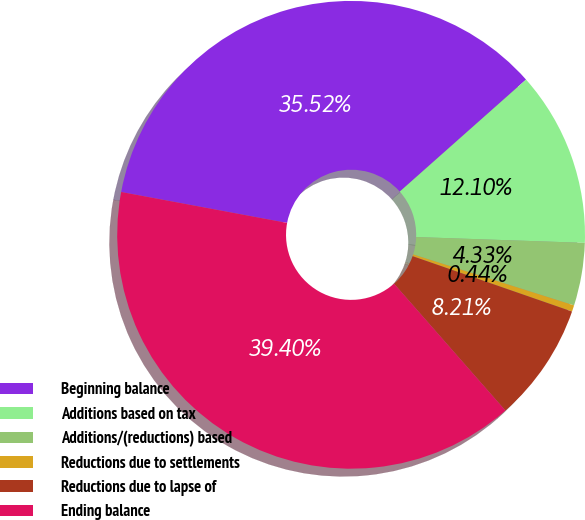<chart> <loc_0><loc_0><loc_500><loc_500><pie_chart><fcel>Beginning balance<fcel>Additions based on tax<fcel>Additions/(reductions) based<fcel>Reductions due to settlements<fcel>Reductions due to lapse of<fcel>Ending balance<nl><fcel>35.52%<fcel>12.1%<fcel>4.33%<fcel>0.44%<fcel>8.21%<fcel>39.4%<nl></chart> 